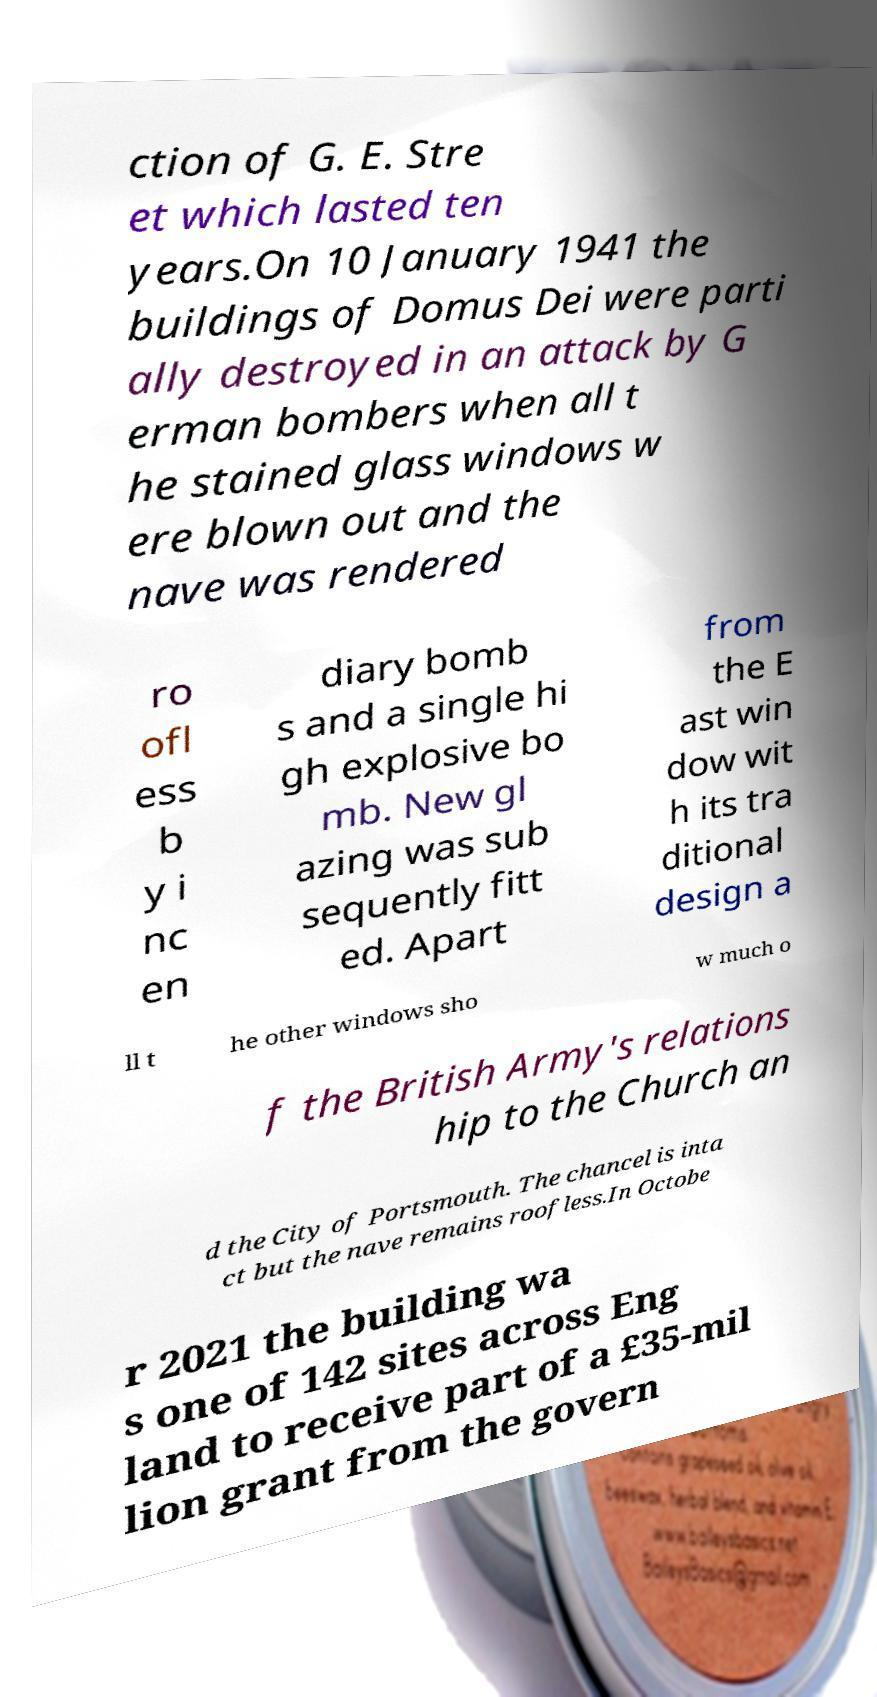Could you assist in decoding the text presented in this image and type it out clearly? ction of G. E. Stre et which lasted ten years.On 10 January 1941 the buildings of Domus Dei were parti ally destroyed in an attack by G erman bombers when all t he stained glass windows w ere blown out and the nave was rendered ro ofl ess b y i nc en diary bomb s and a single hi gh explosive bo mb. New gl azing was sub sequently fitt ed. Apart from the E ast win dow wit h its tra ditional design a ll t he other windows sho w much o f the British Army's relations hip to the Church an d the City of Portsmouth. The chancel is inta ct but the nave remains roofless.In Octobe r 2021 the building wa s one of 142 sites across Eng land to receive part of a £35-mil lion grant from the govern 